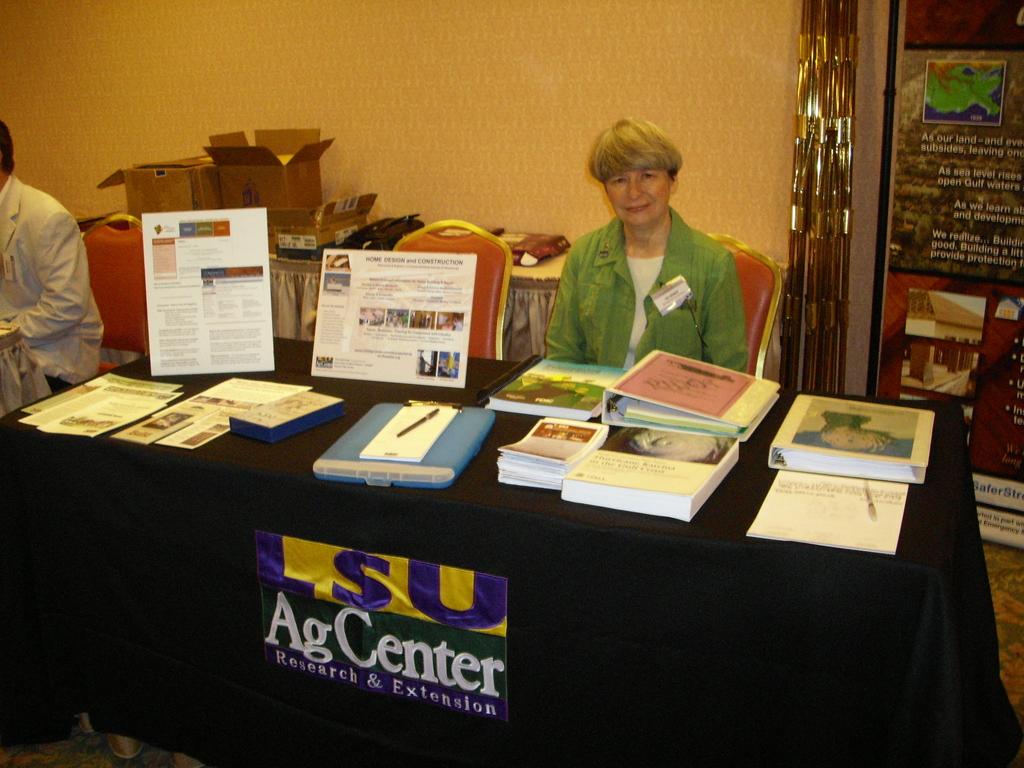What center is being referenced by the sticker on the front of the table?
Provide a short and direct response. Ag center. What do the agcenter do?
Provide a short and direct response. Research and extension. 